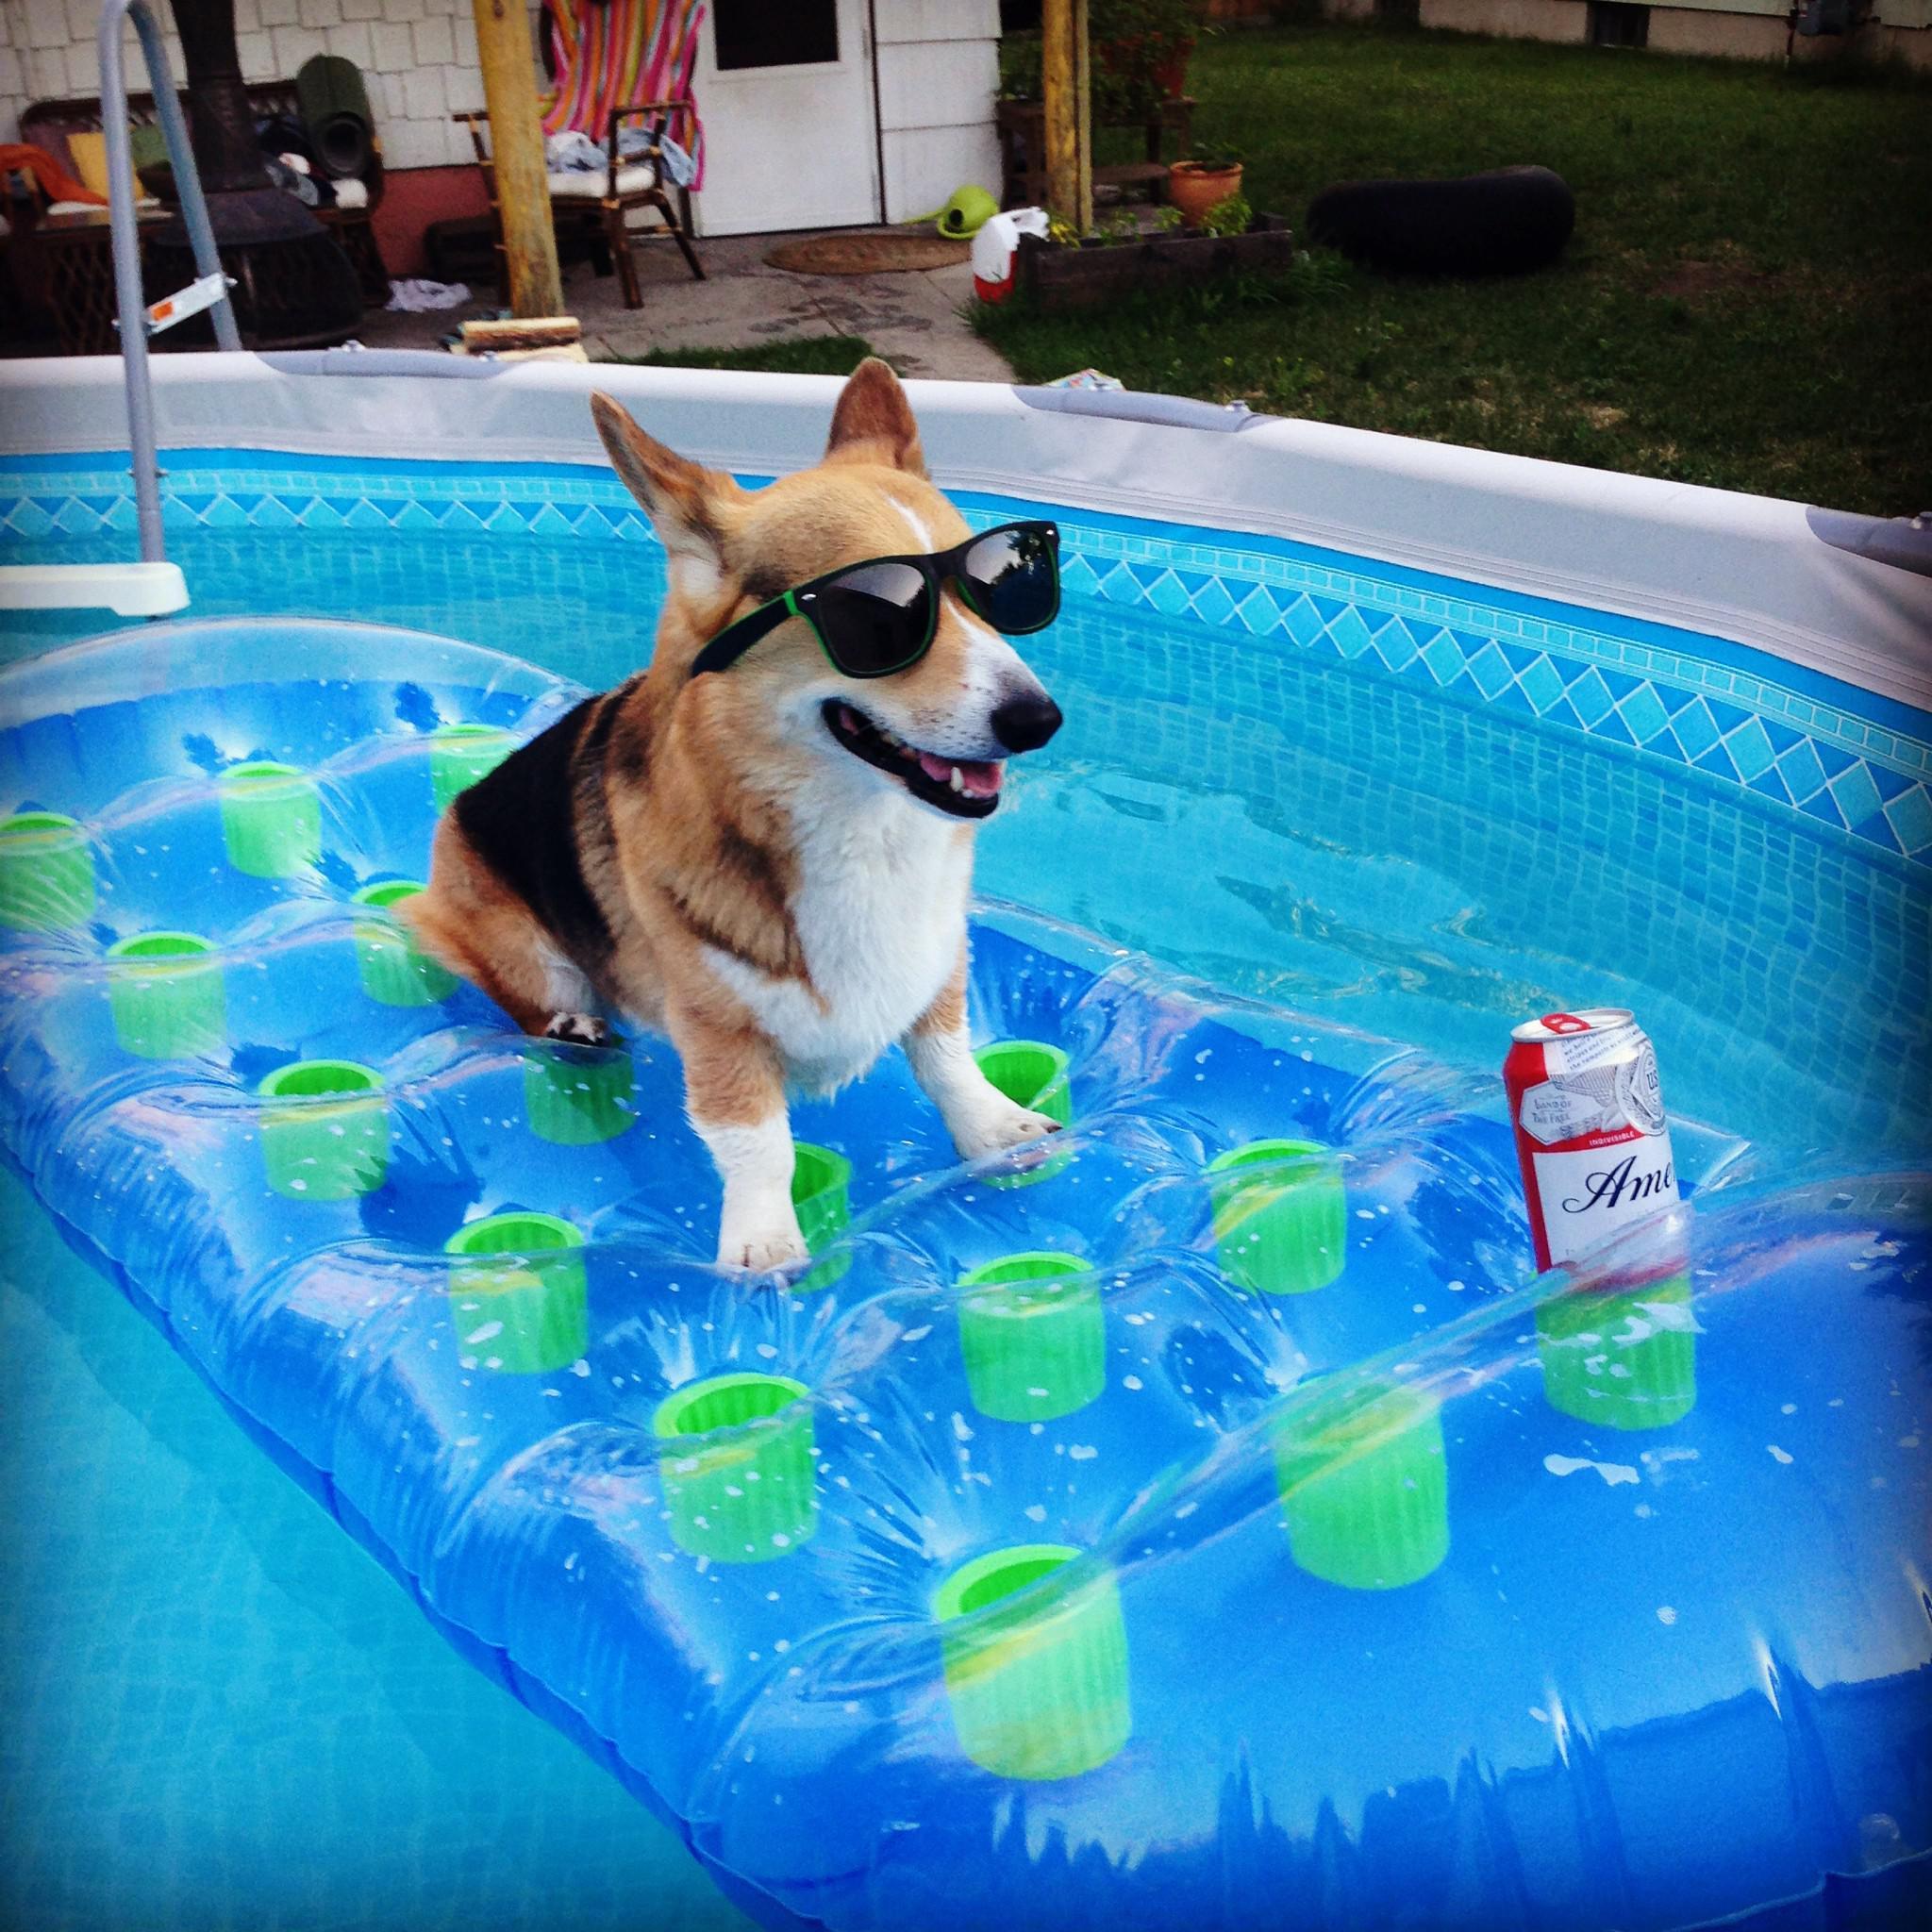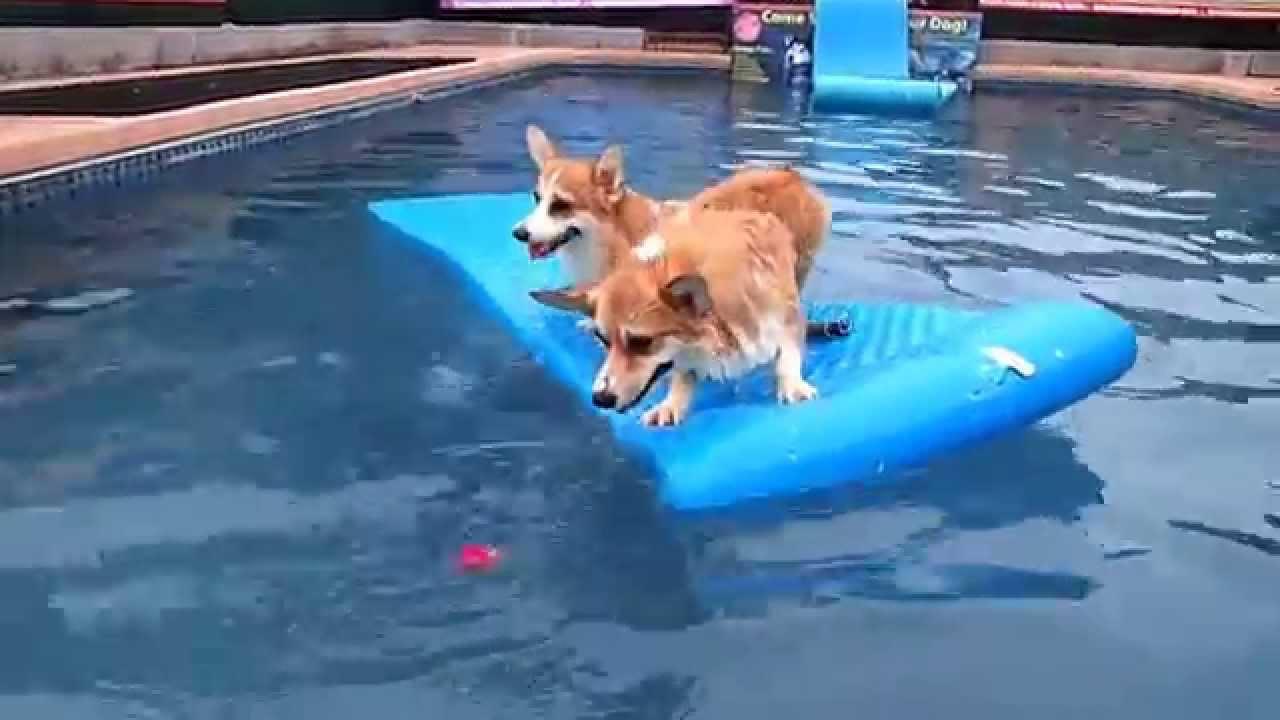The first image is the image on the left, the second image is the image on the right. Examine the images to the left and right. Is the description "In one image there is a corgi riding on a raft in a pool and the other shows at least one dog in a kiddie pool." accurate? Answer yes or no. No. 